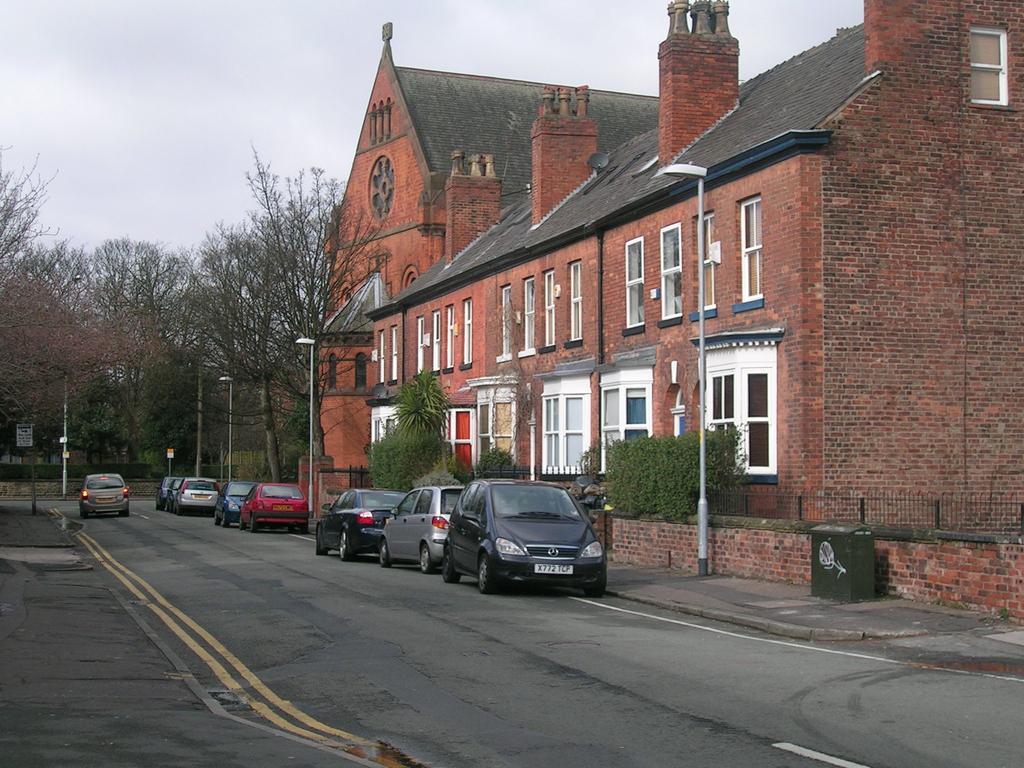Could you give a brief overview of what you see in this image? In this image I can see the road, few vehicles on the road, few poles, few trees and a building which is brown and black in color. I can see few windows of the building and the sky in the background. 